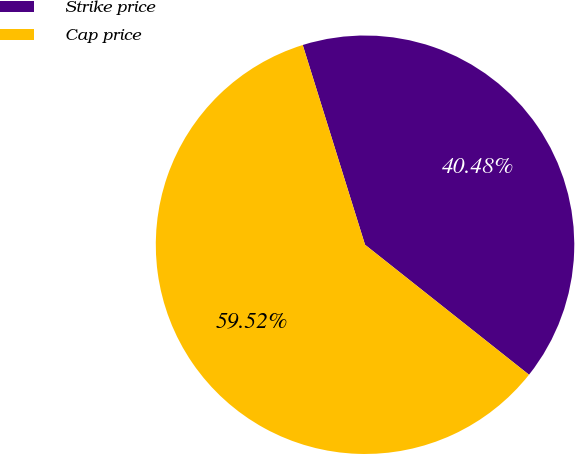Convert chart to OTSL. <chart><loc_0><loc_0><loc_500><loc_500><pie_chart><fcel>Strike price<fcel>Cap price<nl><fcel>40.48%<fcel>59.52%<nl></chart> 